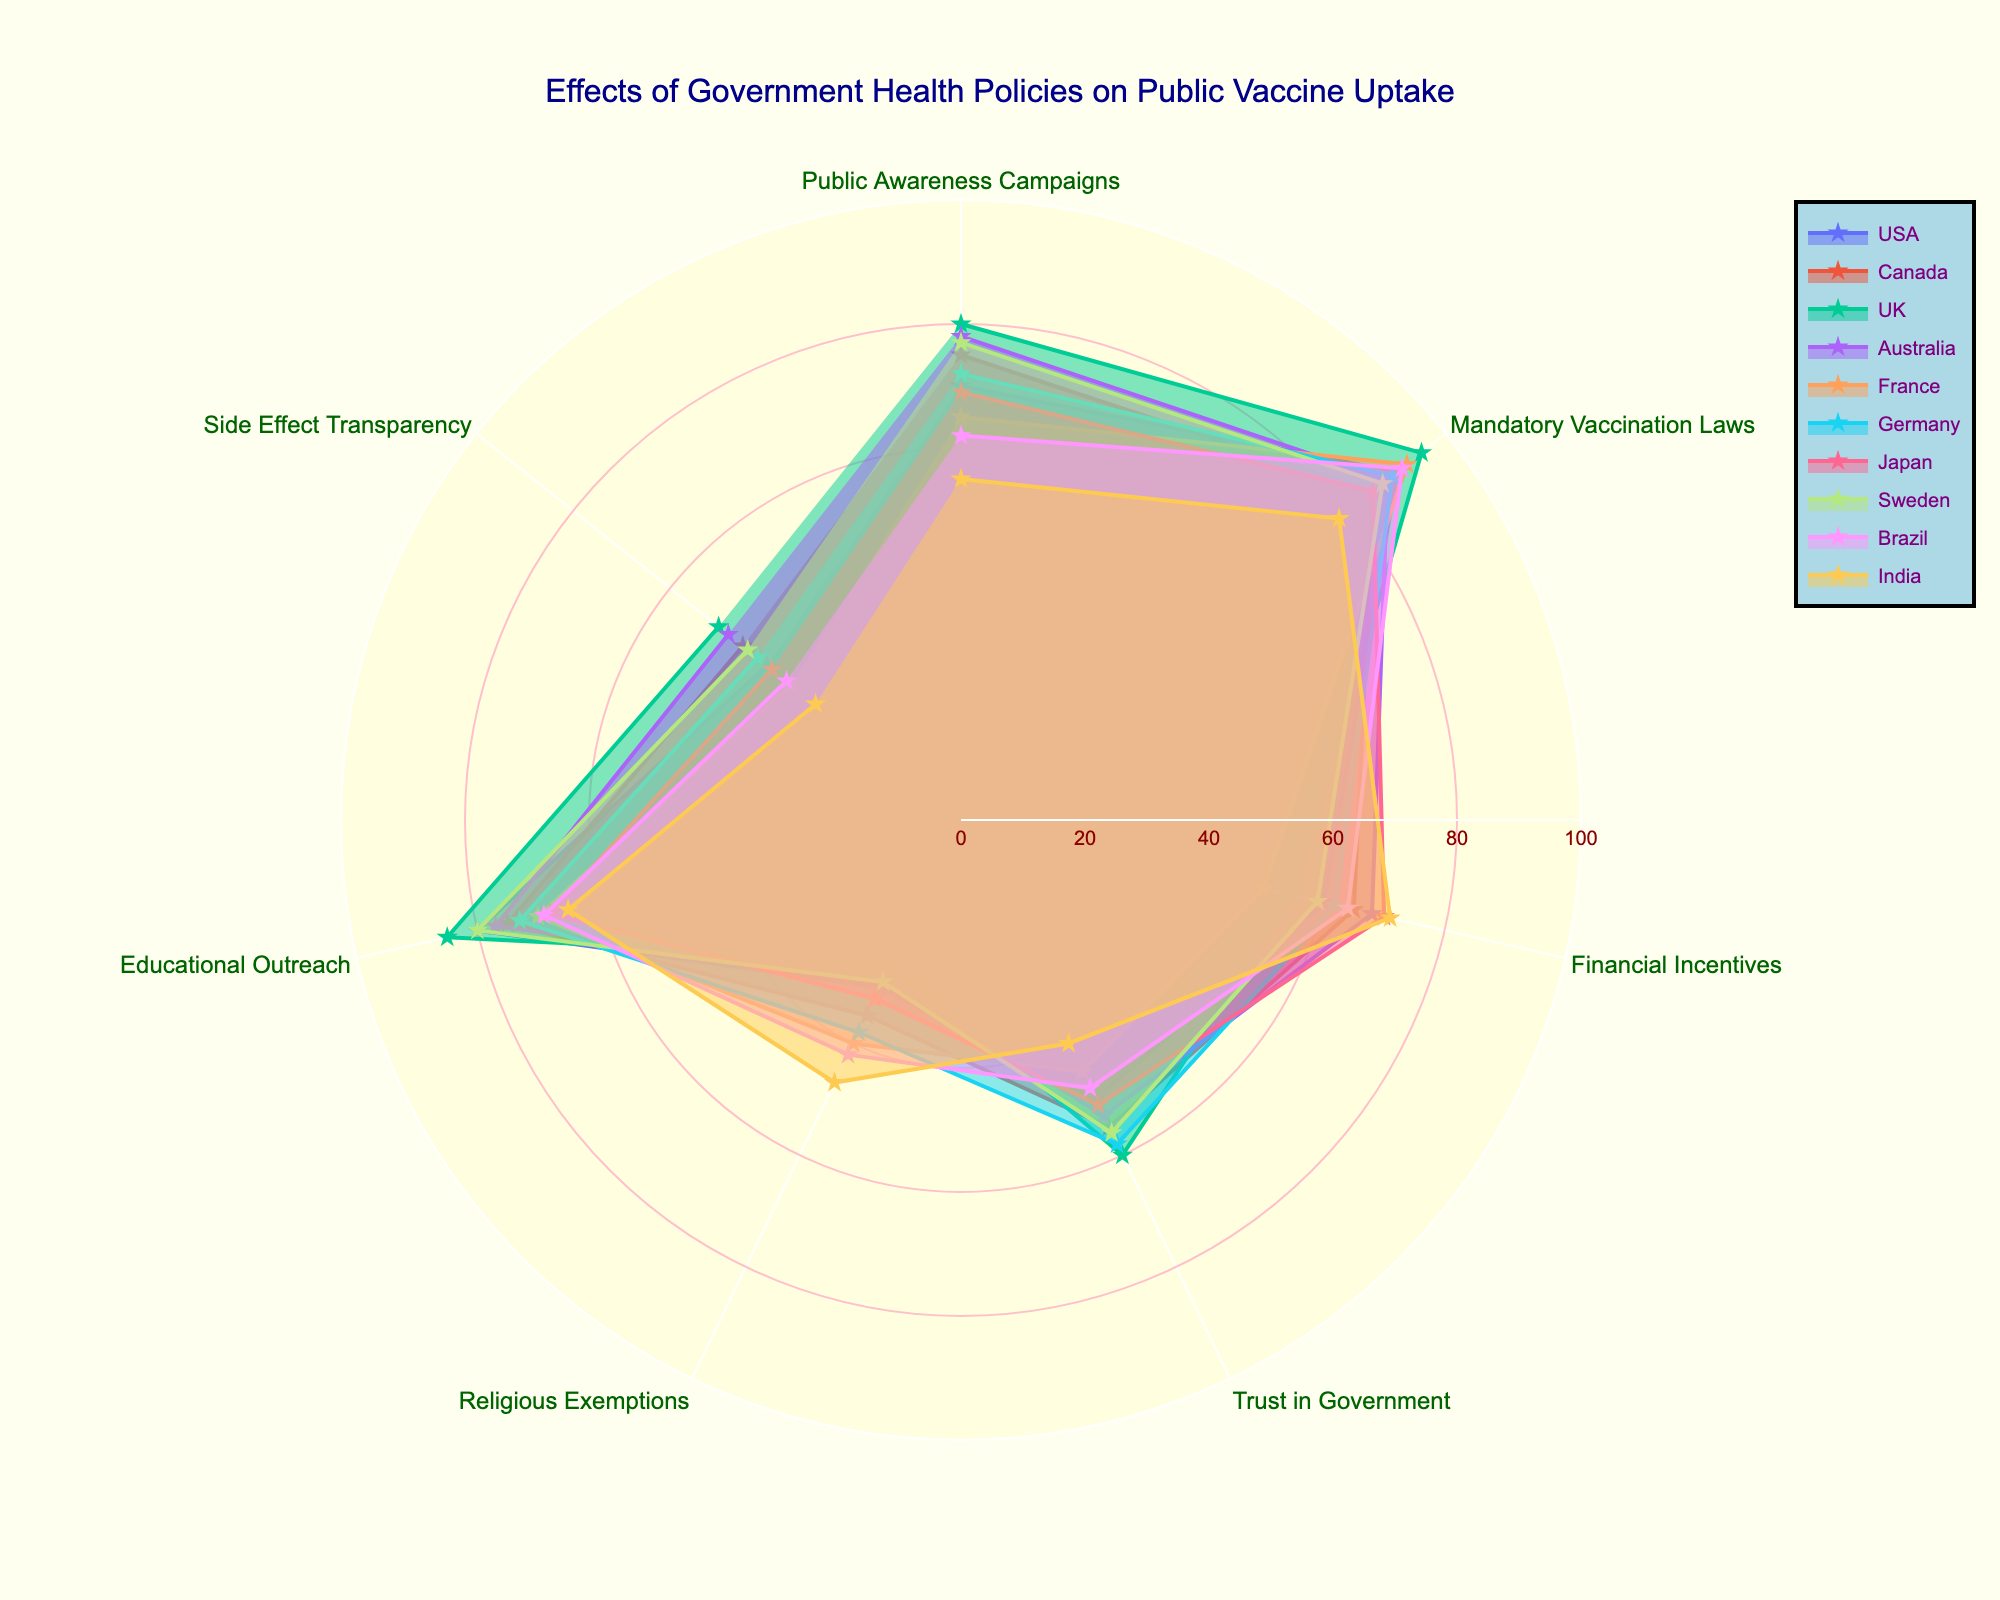what is the title of the radar chart? The title is displayed at the top of the chart and is a descriptive sentence summarizing the main theme of the visualization. From the chart, the title is "Effects of Government Health Policies on Public Vaccine Uptake".
Answer: Effects of Government Health Policies on Public Vaccine Uptake which country has the highest value for ‘Public Awareness Campaigns’? By looking at the section for ‘Public Awareness Campaigns’, the country with the point farthest from the center has the highest value. The UK has the highest value of 80.
Answer: UK what is the difference in ‘Trust in Government’ between the USA and the UK? The value for ‘Trust in Government’ for the USA is 50 and for the UK is 60. The difference is found by subtracting the lower value from the higher value: 60 - 50 = 10.
Answer: 10 which country has the lowest value for ‘Religious Exemptions’? By examining the section for ‘Religious Exemptions’, the country with the point closest to the center has the lowest value. The UK has the lowest value of 25.
Answer: UK among USA, Canada, and Australia, which country has the highest 'Educational Outreach' score? For ‘Educational Outreach’, compare the points for USA (80), Canada (75), and Australia (77). The USA has the highest value of 80.
Answer: USA what is the average 'Side Effect Transparency' score among France, Germany, and Japan? Sum their 'Side Effect Transparency' scores: France (35) + Germany (42) + Japan (39) = 116. Then divide by the number of countries: 116 / 3 ≈ 38.67.
Answer: ≈ 38.67 which regions have ‘Financial Incentives’ scores above 65? Evaluate the 'Financial Incentives' values and identify countries scoring above 65. Japan (70), Australia (68), India (71).
Answer: Japan, Australia, India is there a noticeable trend between 'Mandatory Vaccination Laws' and 'Trust in Government'? Compare ‘Mandatory Vaccination Laws’ and ‘Trust in Government’ to see if they both increase or decrease together. Countries with higher scores in 'Mandatory Vaccination Laws' typically have higher 'Trust in Government' (e.g., UK: 95/60, Germany: 89/58). Yes, there is a trend.
Answer: Yes which policy area has the greatest variance across countries? Compare the spread of points across the categories. 'Side Effect Transparency' appears to have the greatest spread (ranging from 30 in India to 50 in UK).
Answer: Side Effect Transparency 